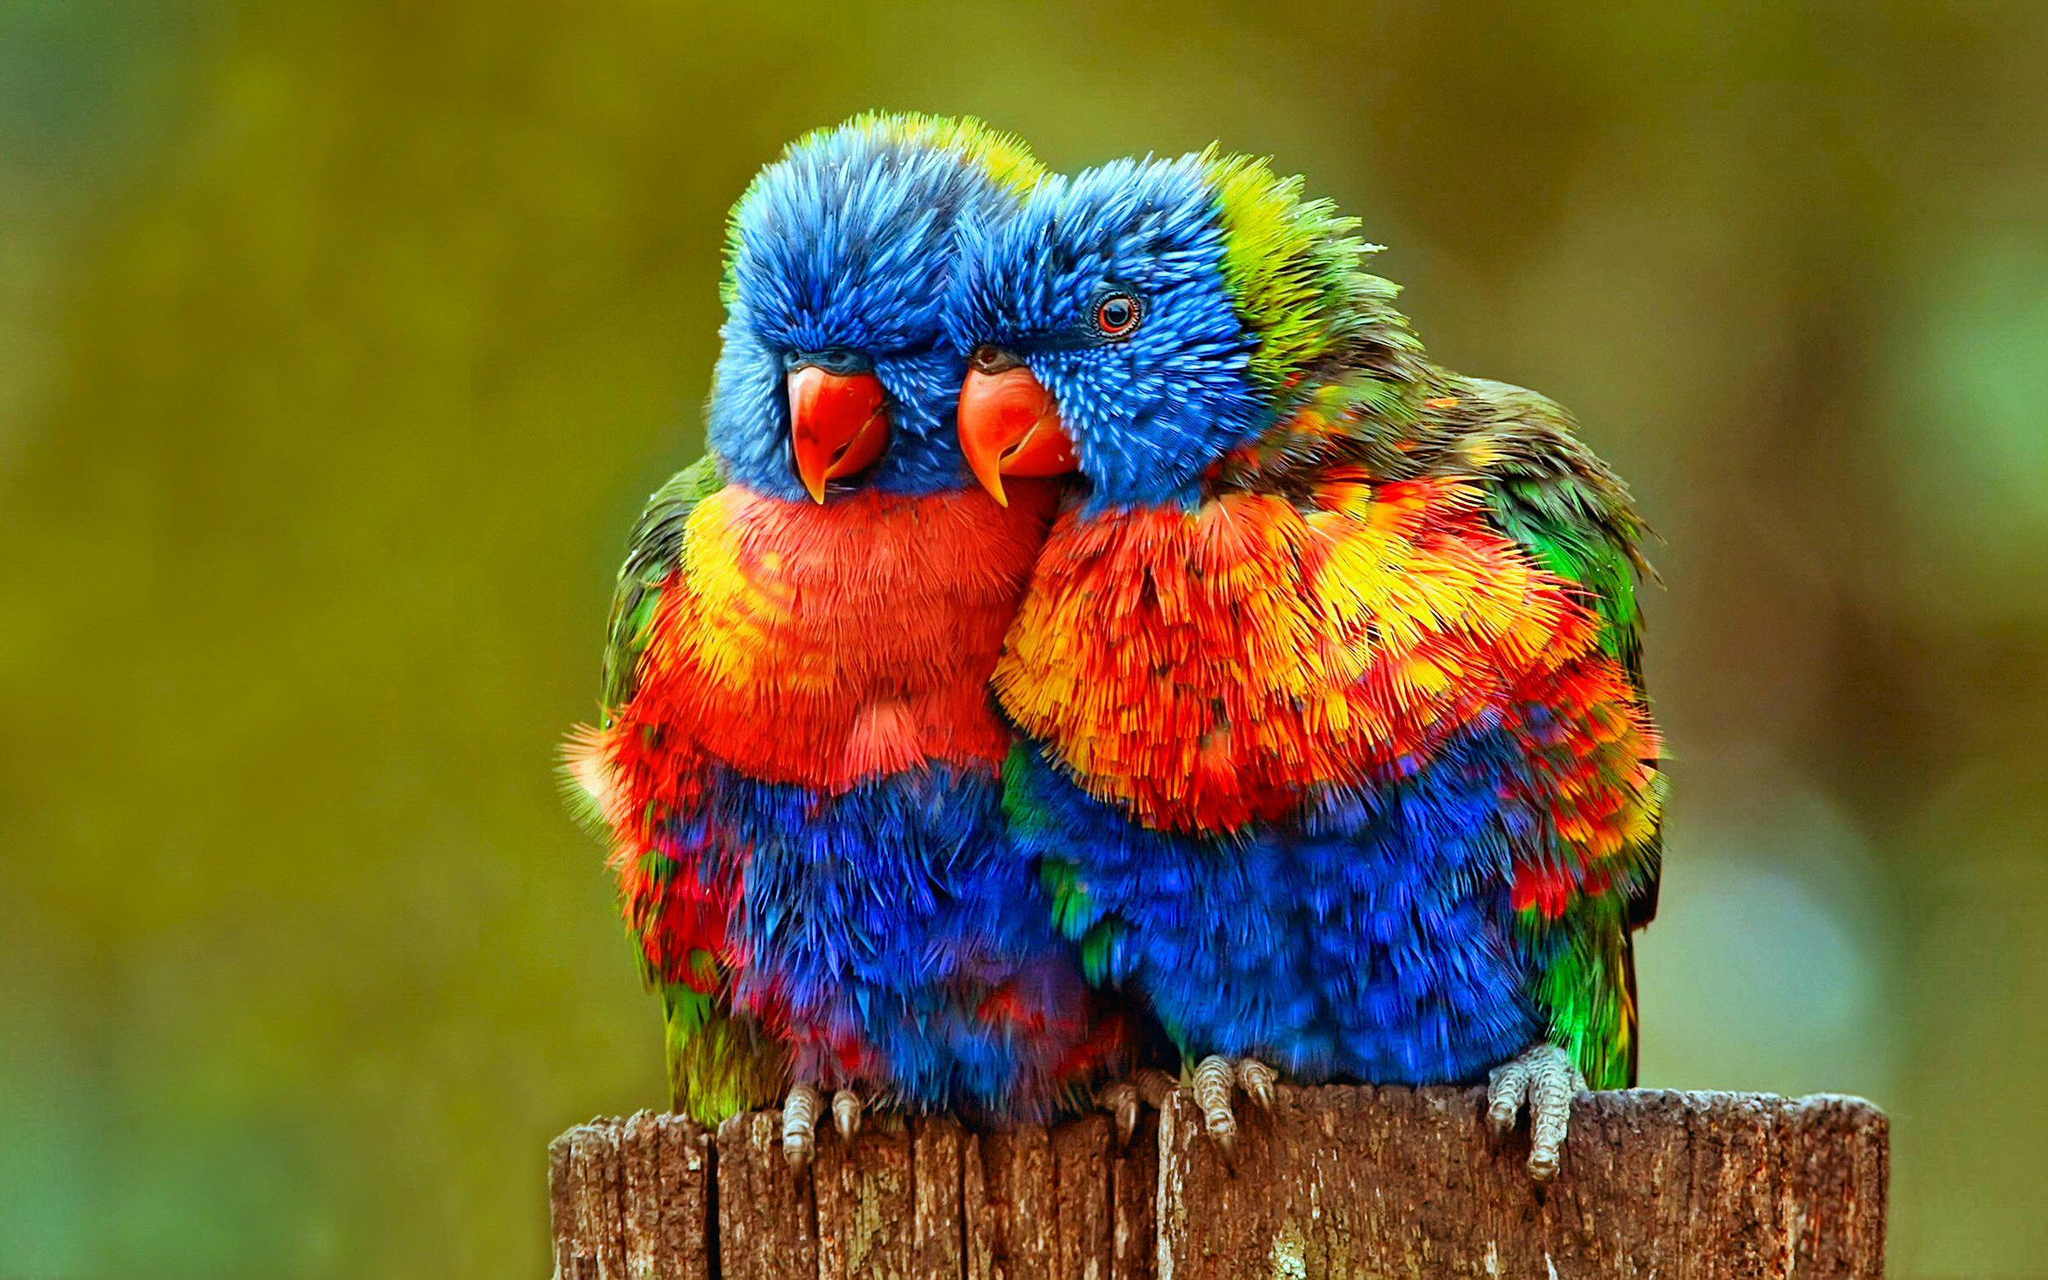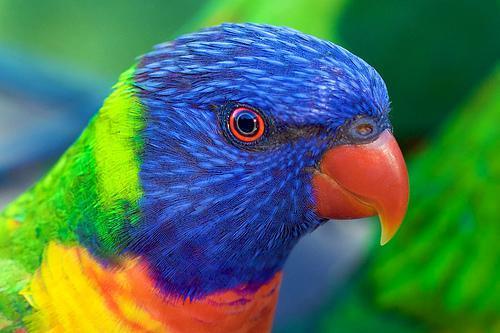The first image is the image on the left, the second image is the image on the right. For the images shown, is this caption "There are more parrots in the left image." true? Answer yes or no. Yes. The first image is the image on the left, the second image is the image on the right. For the images displayed, is the sentence "At least one bird is facing towards the right side of the image." factually correct? Answer yes or no. Yes. The first image is the image on the left, the second image is the image on the right. Evaluate the accuracy of this statement regarding the images: "There are two birds in the image on the right.". Is it true? Answer yes or no. No. 